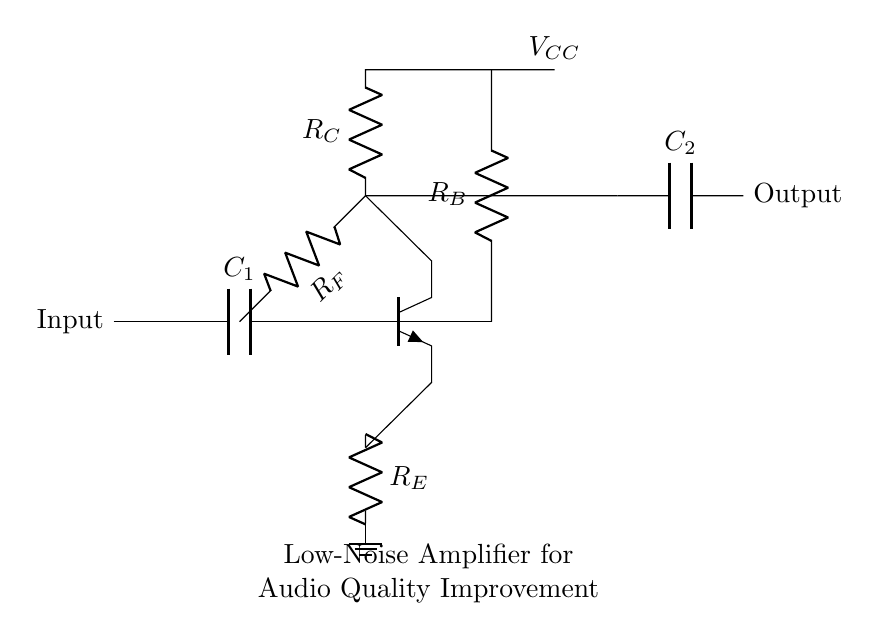What type of amplifier is shown in the circuit? The circuit is labeled as a low-noise amplifier (LNA), which is indicated directly in the diagram.
Answer: Low-noise amplifier What is the purpose of the capacitor labeled C1? Capacitor C1 is located at the input, suggesting its role in coupling AC signals while blocking DC components, thereby improving signal quality.
Answer: Coupling What does the resistor labeled R_E do in this circuit? Resistor R_E is connected to the emitter of the transistor, serving as an emitter resistor which stabilizes the amplifier's operation and sets the emitter current.
Answer: Stabilization What component is connected to the collector of the transistor? The collector of the transistor is connected to resistor R_C, which is responsible for determining the output impedance and gain of the amplifier.
Answer: Resistor R_C How does the feedback resistor R_F affect the circuit? Feedback resistor R_F provides negative feedback from the output to the base, which improves linearity and bandwidth in the amplifier performance.
Answer: Improves linearity What is the output configuration of this amplifier? The output configuration is a capacitive coupling, as indicated by capacitor C2 connected at the output node, effectively allowing the AC signal to pass while blocking DC.
Answer: Capacitive coupling What voltage is labeled as V_CC in this circuit? V_CC is the supply voltage connected to the collector through R_C, which powers the amplifier circuit, ensuring proper biasing and operation of the transistor.
Answer: Supply voltage 